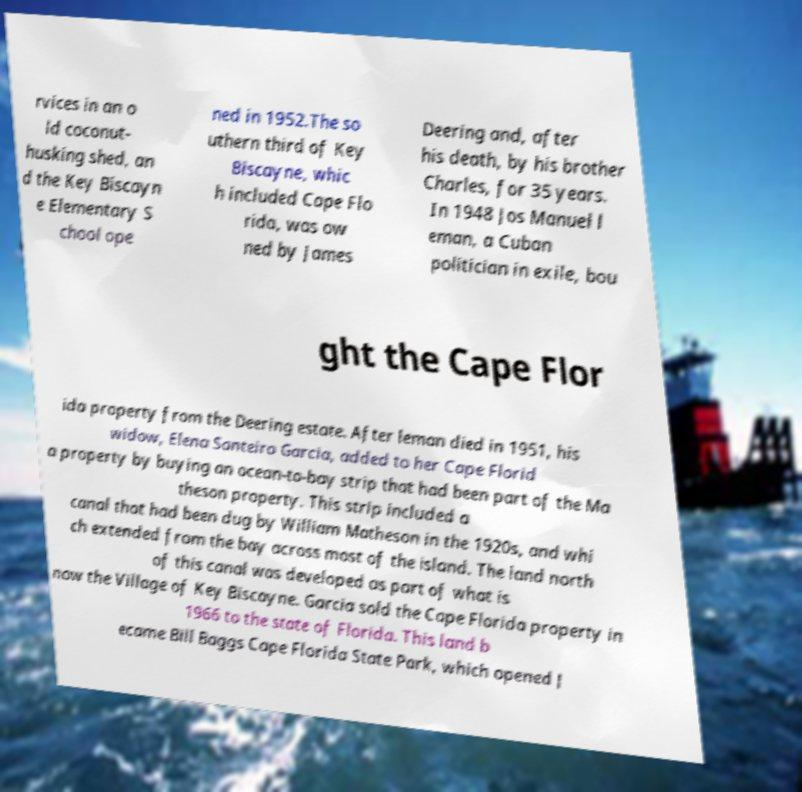For documentation purposes, I need the text within this image transcribed. Could you provide that? rvices in an o ld coconut- husking shed, an d the Key Biscayn e Elementary S chool ope ned in 1952.The so uthern third of Key Biscayne, whic h included Cape Flo rida, was ow ned by James Deering and, after his death, by his brother Charles, for 35 years. In 1948 Jos Manuel l eman, a Cuban politician in exile, bou ght the Cape Flor ida property from the Deering estate. After leman died in 1951, his widow, Elena Santeiro Garcia, added to her Cape Florid a property by buying an ocean-to-bay strip that had been part of the Ma theson property. This strip included a canal that had been dug by William Matheson in the 1920s, and whi ch extended from the bay across most of the island. The land north of this canal was developed as part of what is now the Village of Key Biscayne. Garcia sold the Cape Florida property in 1966 to the state of Florida. This land b ecame Bill Baggs Cape Florida State Park, which opened J 